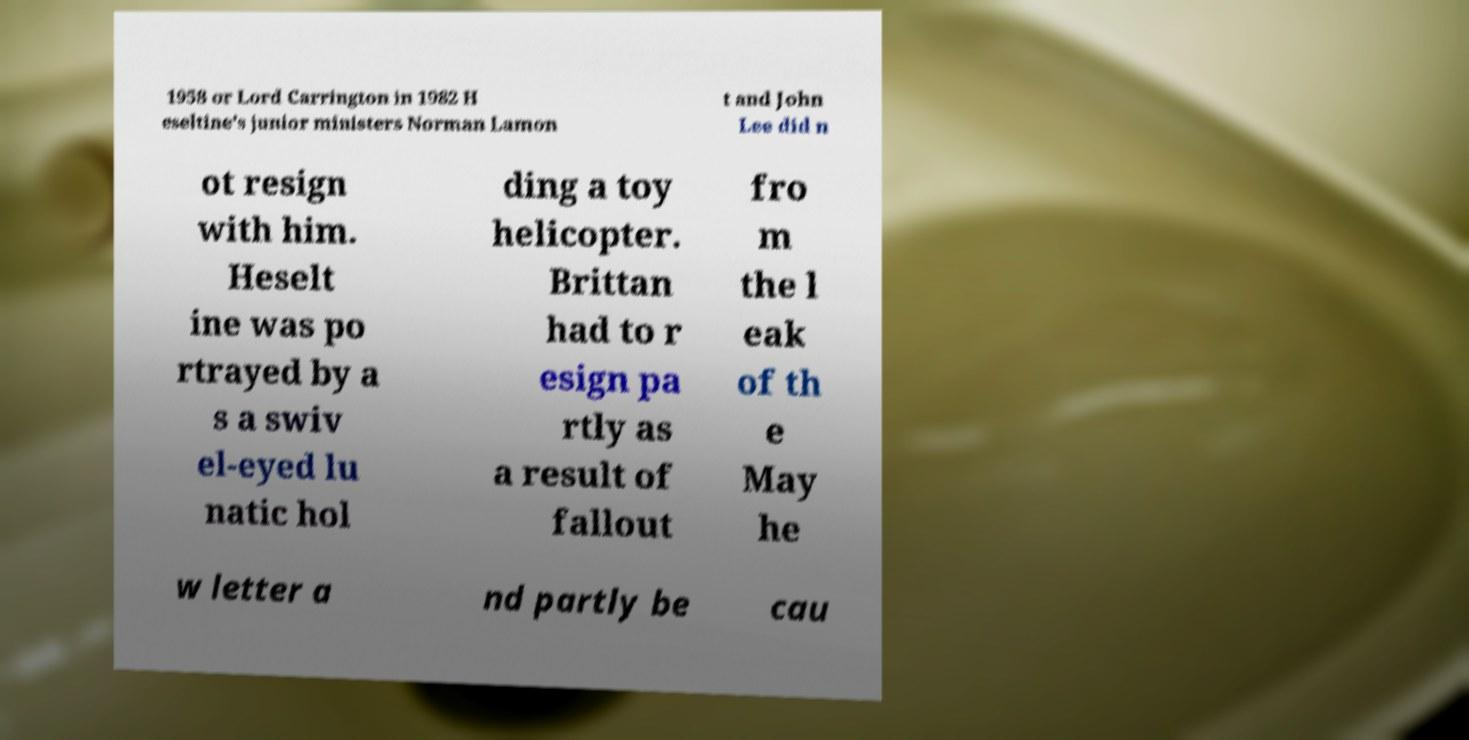What messages or text are displayed in this image? I need them in a readable, typed format. 1958 or Lord Carrington in 1982 H eseltine's junior ministers Norman Lamon t and John Lee did n ot resign with him. Heselt ine was po rtrayed by a s a swiv el-eyed lu natic hol ding a toy helicopter. Brittan had to r esign pa rtly as a result of fallout fro m the l eak of th e May he w letter a nd partly be cau 